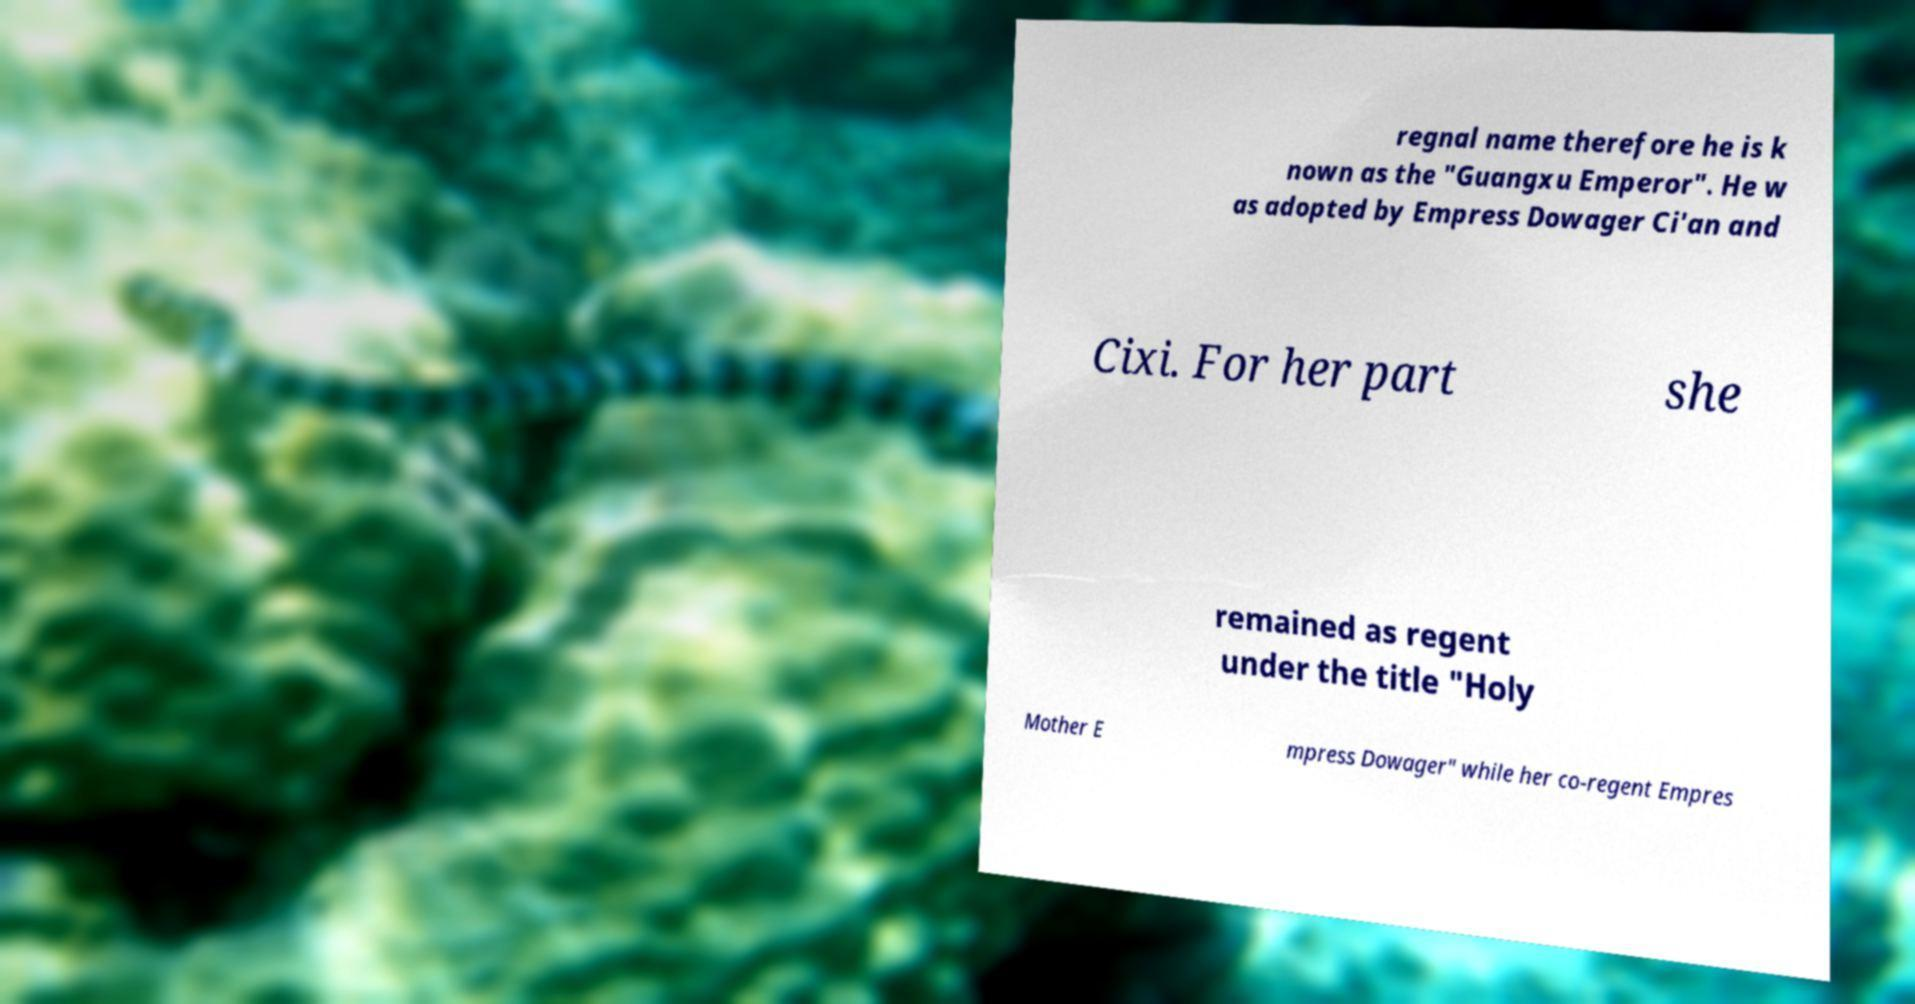Can you accurately transcribe the text from the provided image for me? regnal name therefore he is k nown as the "Guangxu Emperor". He w as adopted by Empress Dowager Ci'an and Cixi. For her part she remained as regent under the title "Holy Mother E mpress Dowager" while her co-regent Empres 